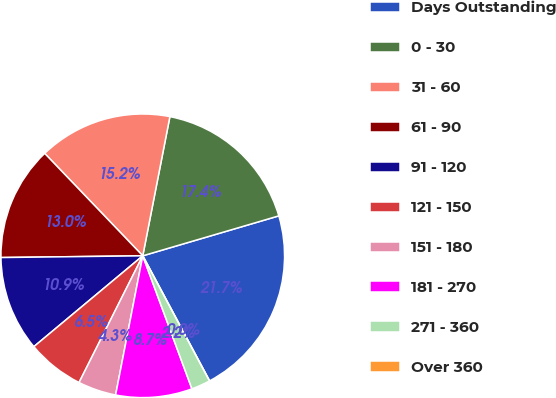Convert chart. <chart><loc_0><loc_0><loc_500><loc_500><pie_chart><fcel>Days Outstanding<fcel>0 - 30<fcel>31 - 60<fcel>61 - 90<fcel>91 - 120<fcel>121 - 150<fcel>151 - 180<fcel>181 - 270<fcel>271 - 360<fcel>Over 360<nl><fcel>21.74%<fcel>17.39%<fcel>15.22%<fcel>13.04%<fcel>10.87%<fcel>6.52%<fcel>4.35%<fcel>8.7%<fcel>2.17%<fcel>0.0%<nl></chart> 